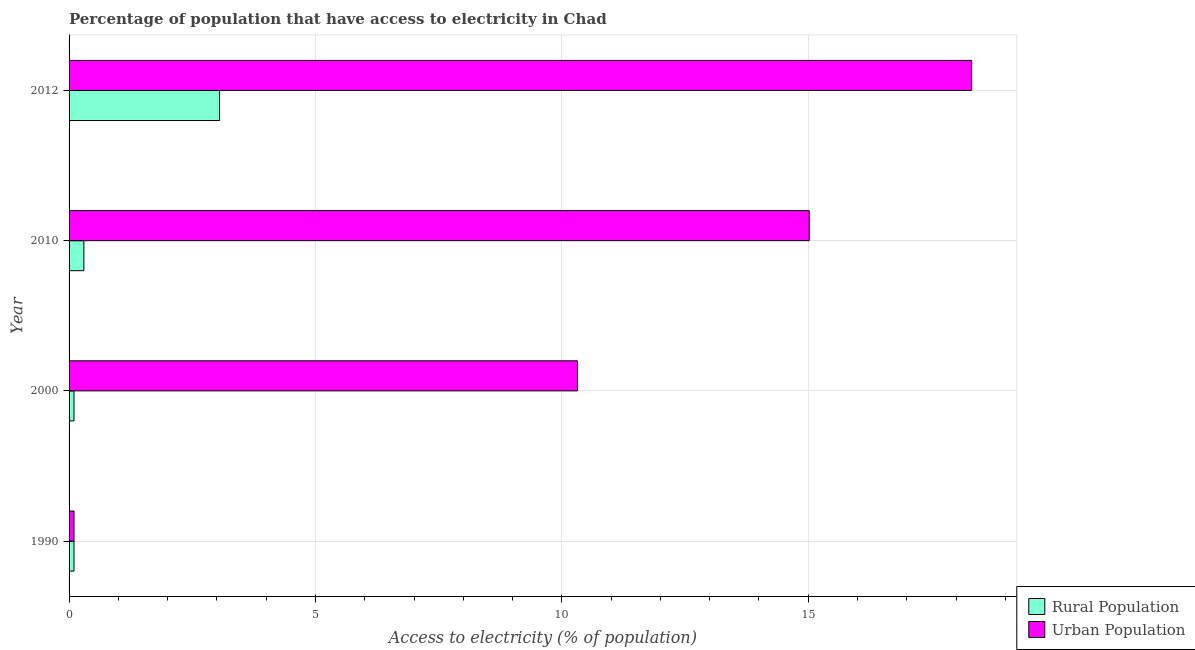How many groups of bars are there?
Ensure brevity in your answer.  4. Are the number of bars per tick equal to the number of legend labels?
Give a very brief answer. Yes. How many bars are there on the 1st tick from the top?
Ensure brevity in your answer.  2. How many bars are there on the 3rd tick from the bottom?
Your answer should be very brief. 2. What is the label of the 1st group of bars from the top?
Offer a terse response. 2012. In how many cases, is the number of bars for a given year not equal to the number of legend labels?
Offer a terse response. 0. What is the percentage of urban population having access to electricity in 2012?
Your response must be concise. 18.32. Across all years, what is the maximum percentage of urban population having access to electricity?
Offer a very short reply. 18.32. Across all years, what is the minimum percentage of rural population having access to electricity?
Offer a terse response. 0.1. In which year was the percentage of rural population having access to electricity minimum?
Offer a very short reply. 1990. What is the total percentage of urban population having access to electricity in the graph?
Provide a short and direct response. 43.75. What is the difference between the percentage of urban population having access to electricity in 1990 and that in 2010?
Your answer should be very brief. -14.92. What is the difference between the percentage of urban population having access to electricity in 2000 and the percentage of rural population having access to electricity in 1990?
Your answer should be compact. 10.22. What is the average percentage of rural population having access to electricity per year?
Provide a short and direct response. 0.89. In the year 2000, what is the difference between the percentage of rural population having access to electricity and percentage of urban population having access to electricity?
Your answer should be very brief. -10.22. In how many years, is the percentage of urban population having access to electricity greater than 8 %?
Your response must be concise. 3. What is the ratio of the percentage of urban population having access to electricity in 2000 to that in 2012?
Provide a short and direct response. 0.56. Is the difference between the percentage of urban population having access to electricity in 1990 and 2012 greater than the difference between the percentage of rural population having access to electricity in 1990 and 2012?
Keep it short and to the point. No. What is the difference between the highest and the second highest percentage of urban population having access to electricity?
Provide a succinct answer. 3.3. What is the difference between the highest and the lowest percentage of rural population having access to electricity?
Offer a very short reply. 2.95. In how many years, is the percentage of urban population having access to electricity greater than the average percentage of urban population having access to electricity taken over all years?
Your answer should be very brief. 2. What does the 1st bar from the top in 2012 represents?
Provide a succinct answer. Urban Population. What does the 2nd bar from the bottom in 2000 represents?
Provide a succinct answer. Urban Population. How many bars are there?
Provide a short and direct response. 8. What is the difference between two consecutive major ticks on the X-axis?
Give a very brief answer. 5. Are the values on the major ticks of X-axis written in scientific E-notation?
Offer a very short reply. No. Does the graph contain any zero values?
Provide a short and direct response. No. How are the legend labels stacked?
Offer a very short reply. Vertical. What is the title of the graph?
Keep it short and to the point. Percentage of population that have access to electricity in Chad. Does "Money lenders" appear as one of the legend labels in the graph?
Give a very brief answer. No. What is the label or title of the X-axis?
Your response must be concise. Access to electricity (% of population). What is the Access to electricity (% of population) of Urban Population in 2000?
Make the answer very short. 10.32. What is the Access to electricity (% of population) in Urban Population in 2010?
Offer a very short reply. 15.02. What is the Access to electricity (% of population) in Rural Population in 2012?
Your answer should be very brief. 3.05. What is the Access to electricity (% of population) of Urban Population in 2012?
Ensure brevity in your answer.  18.32. Across all years, what is the maximum Access to electricity (% of population) in Rural Population?
Give a very brief answer. 3.05. Across all years, what is the maximum Access to electricity (% of population) of Urban Population?
Your answer should be compact. 18.32. Across all years, what is the minimum Access to electricity (% of population) in Urban Population?
Make the answer very short. 0.1. What is the total Access to electricity (% of population) in Rural Population in the graph?
Provide a short and direct response. 3.55. What is the total Access to electricity (% of population) of Urban Population in the graph?
Keep it short and to the point. 43.75. What is the difference between the Access to electricity (% of population) in Urban Population in 1990 and that in 2000?
Your answer should be compact. -10.22. What is the difference between the Access to electricity (% of population) in Urban Population in 1990 and that in 2010?
Give a very brief answer. -14.92. What is the difference between the Access to electricity (% of population) of Rural Population in 1990 and that in 2012?
Make the answer very short. -2.95. What is the difference between the Access to electricity (% of population) of Urban Population in 1990 and that in 2012?
Your answer should be compact. -18.22. What is the difference between the Access to electricity (% of population) in Rural Population in 2000 and that in 2010?
Provide a short and direct response. -0.2. What is the difference between the Access to electricity (% of population) of Urban Population in 2000 and that in 2010?
Keep it short and to the point. -4.7. What is the difference between the Access to electricity (% of population) in Rural Population in 2000 and that in 2012?
Make the answer very short. -2.95. What is the difference between the Access to electricity (% of population) of Urban Population in 2000 and that in 2012?
Provide a short and direct response. -8. What is the difference between the Access to electricity (% of population) in Rural Population in 2010 and that in 2012?
Make the answer very short. -2.75. What is the difference between the Access to electricity (% of population) of Urban Population in 2010 and that in 2012?
Provide a short and direct response. -3.3. What is the difference between the Access to electricity (% of population) of Rural Population in 1990 and the Access to electricity (% of population) of Urban Population in 2000?
Keep it short and to the point. -10.22. What is the difference between the Access to electricity (% of population) of Rural Population in 1990 and the Access to electricity (% of population) of Urban Population in 2010?
Provide a succinct answer. -14.92. What is the difference between the Access to electricity (% of population) in Rural Population in 1990 and the Access to electricity (% of population) in Urban Population in 2012?
Keep it short and to the point. -18.22. What is the difference between the Access to electricity (% of population) of Rural Population in 2000 and the Access to electricity (% of population) of Urban Population in 2010?
Make the answer very short. -14.92. What is the difference between the Access to electricity (% of population) in Rural Population in 2000 and the Access to electricity (% of population) in Urban Population in 2012?
Your response must be concise. -18.22. What is the difference between the Access to electricity (% of population) of Rural Population in 2010 and the Access to electricity (% of population) of Urban Population in 2012?
Make the answer very short. -18.02. What is the average Access to electricity (% of population) of Rural Population per year?
Offer a terse response. 0.89. What is the average Access to electricity (% of population) in Urban Population per year?
Make the answer very short. 10.94. In the year 1990, what is the difference between the Access to electricity (% of population) in Rural Population and Access to electricity (% of population) in Urban Population?
Make the answer very short. 0. In the year 2000, what is the difference between the Access to electricity (% of population) of Rural Population and Access to electricity (% of population) of Urban Population?
Your answer should be compact. -10.22. In the year 2010, what is the difference between the Access to electricity (% of population) of Rural Population and Access to electricity (% of population) of Urban Population?
Provide a succinct answer. -14.72. In the year 2012, what is the difference between the Access to electricity (% of population) in Rural Population and Access to electricity (% of population) in Urban Population?
Provide a succinct answer. -15.26. What is the ratio of the Access to electricity (% of population) of Urban Population in 1990 to that in 2000?
Make the answer very short. 0.01. What is the ratio of the Access to electricity (% of population) in Urban Population in 1990 to that in 2010?
Your response must be concise. 0.01. What is the ratio of the Access to electricity (% of population) of Rural Population in 1990 to that in 2012?
Your response must be concise. 0.03. What is the ratio of the Access to electricity (% of population) in Urban Population in 1990 to that in 2012?
Your response must be concise. 0.01. What is the ratio of the Access to electricity (% of population) in Urban Population in 2000 to that in 2010?
Your response must be concise. 0.69. What is the ratio of the Access to electricity (% of population) of Rural Population in 2000 to that in 2012?
Ensure brevity in your answer.  0.03. What is the ratio of the Access to electricity (% of population) of Urban Population in 2000 to that in 2012?
Your answer should be very brief. 0.56. What is the ratio of the Access to electricity (% of population) in Rural Population in 2010 to that in 2012?
Your answer should be very brief. 0.1. What is the ratio of the Access to electricity (% of population) of Urban Population in 2010 to that in 2012?
Your response must be concise. 0.82. What is the difference between the highest and the second highest Access to electricity (% of population) in Rural Population?
Give a very brief answer. 2.75. What is the difference between the highest and the second highest Access to electricity (% of population) of Urban Population?
Make the answer very short. 3.3. What is the difference between the highest and the lowest Access to electricity (% of population) in Rural Population?
Give a very brief answer. 2.95. What is the difference between the highest and the lowest Access to electricity (% of population) in Urban Population?
Offer a very short reply. 18.22. 